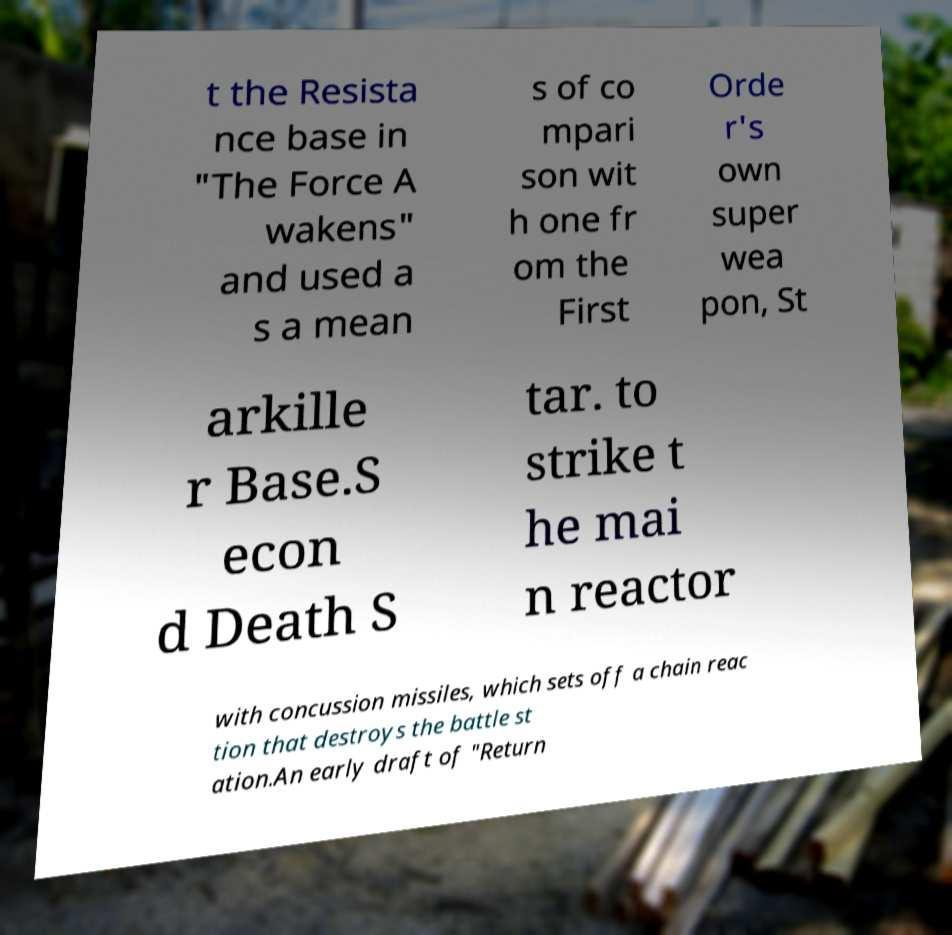Please read and relay the text visible in this image. What does it say? t the Resista nce base in "The Force A wakens" and used a s a mean s of co mpari son wit h one fr om the First Orde r's own super wea pon, St arkille r Base.S econ d Death S tar. to strike t he mai n reactor with concussion missiles, which sets off a chain reac tion that destroys the battle st ation.An early draft of "Return 